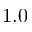<formula> <loc_0><loc_0><loc_500><loc_500>1 . 0</formula> 